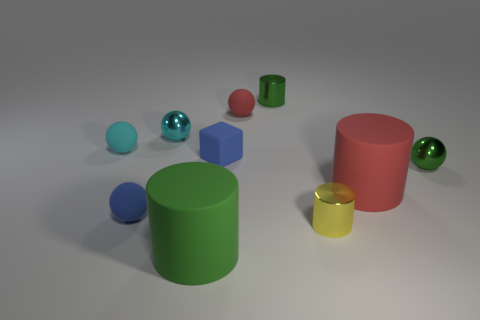Subtract all green metal balls. How many balls are left? 4 Subtract all blue spheres. How many spheres are left? 4 Subtract 1 cylinders. How many cylinders are left? 3 Subtract all yellow spheres. Subtract all green cubes. How many spheres are left? 5 Subtract all cylinders. How many objects are left? 6 Add 3 blue matte things. How many blue matte things exist? 5 Subtract 0 purple spheres. How many objects are left? 10 Subtract all big green matte cylinders. Subtract all big red rubber objects. How many objects are left? 8 Add 6 tiny cyan metal balls. How many tiny cyan metal balls are left? 7 